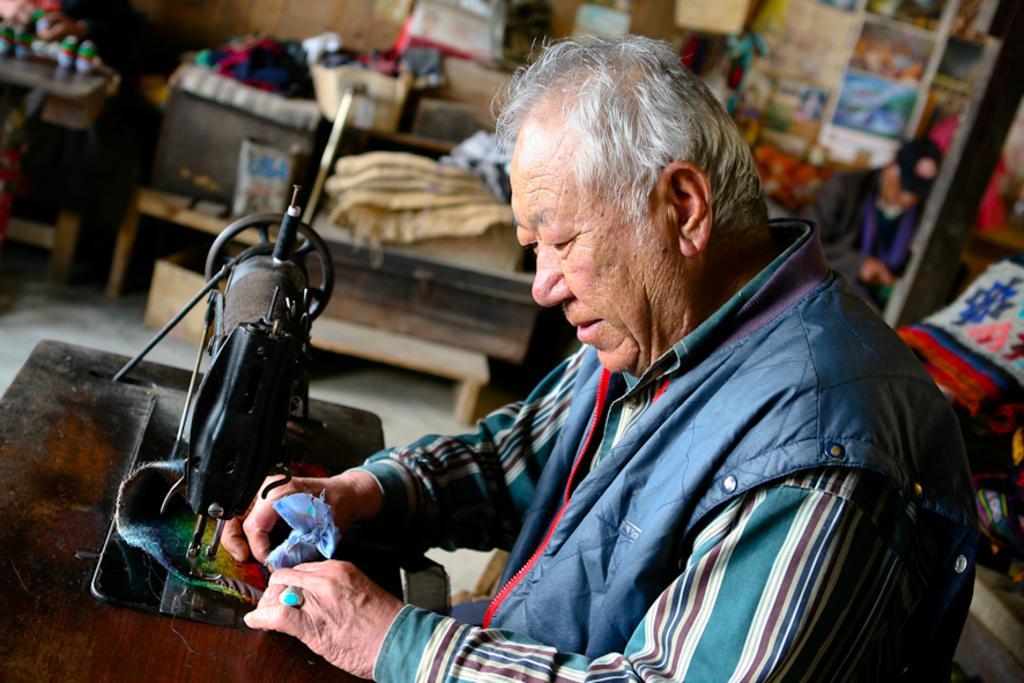Could you give a brief overview of what you see in this image? In this picture, we see a man in the blue jacket is sitting. He is sewing clothes and in front of him, we see a sewing machine. On the right side, we see the clothes and a wooden pole. Beside that, we see a man is sitting. Beside him, we see a table on which clothes and the wooden objects are placed. In the background, we see a wall on which photo frames and the posters are pasted. On the left side, we see a table on which the clothes are placed. This picture is blurred in the background. 